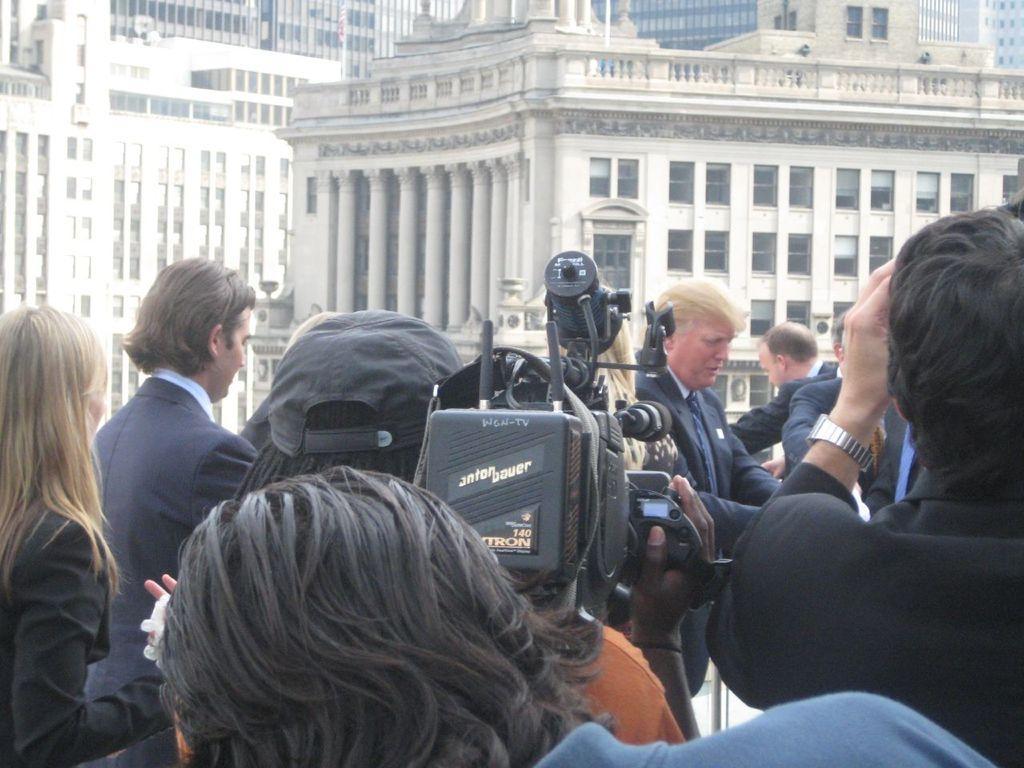Please provide a concise description of this image. In the image I can see a group of people are standing among them the person in the middle is holding a video camera in hands. In the background I can see buildings. 